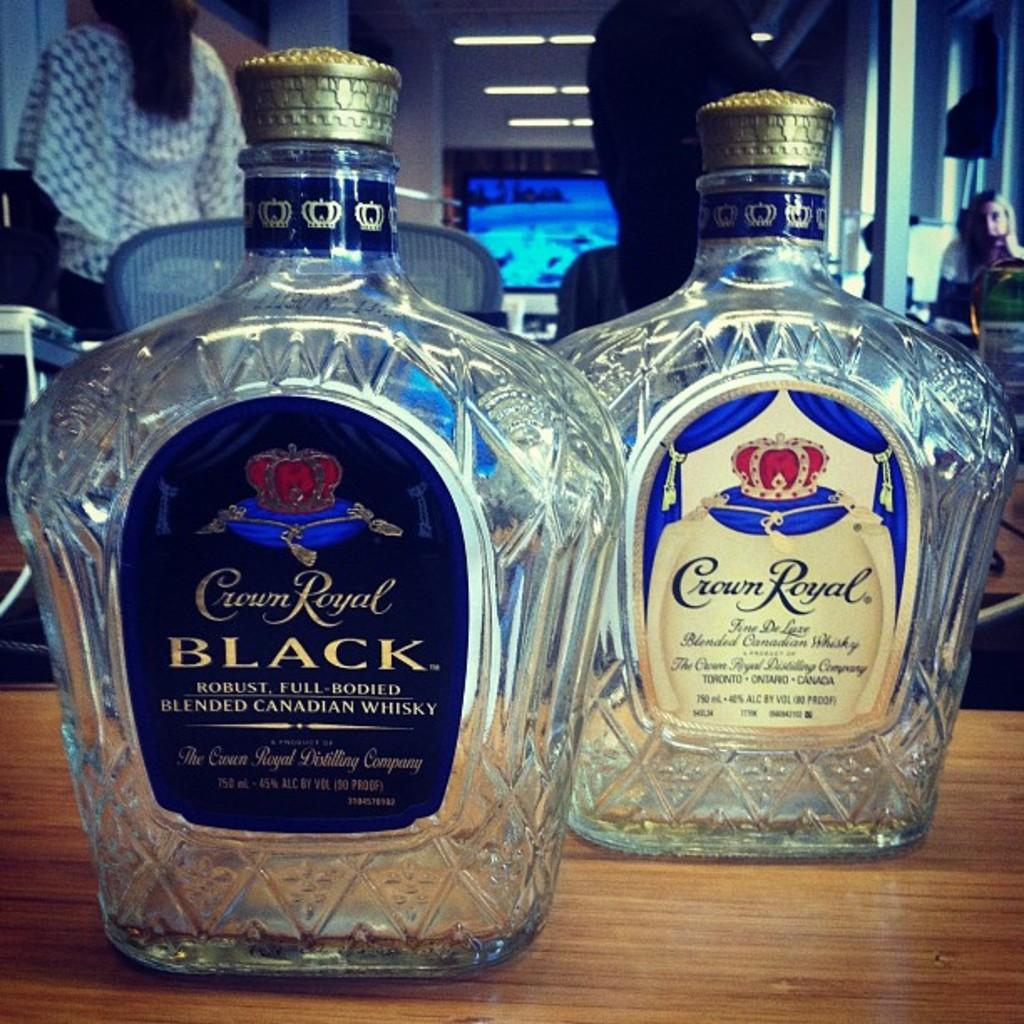What objects are present in the image related to wine? There are two empty wine bottles in the image. Where are the wine bottles located? The wine bottles are on a table. What type of camping equipment can be seen in the image? There is no camping equipment present in the image; it features two empty wine bottles on a table. What type of needle is used to open the wine bottles in the image? There is no needle present in the image, and wine bottles are typically opened using a corkscrew or other wine opener. 